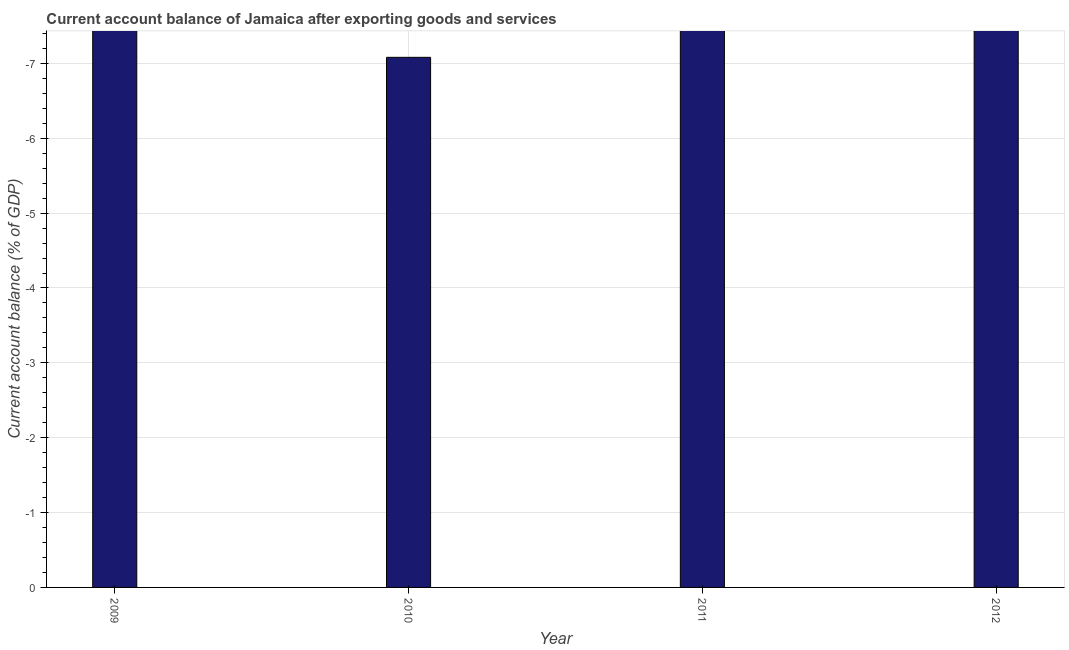What is the title of the graph?
Offer a very short reply. Current account balance of Jamaica after exporting goods and services. What is the label or title of the X-axis?
Your answer should be compact. Year. What is the label or title of the Y-axis?
Your answer should be very brief. Current account balance (% of GDP). What is the current account balance in 2010?
Give a very brief answer. 0. Across all years, what is the minimum current account balance?
Give a very brief answer. 0. What is the sum of the current account balance?
Offer a very short reply. 0. What is the median current account balance?
Provide a succinct answer. 0. In how many years, is the current account balance greater than the average current account balance taken over all years?
Your response must be concise. 0. How many years are there in the graph?
Make the answer very short. 4. What is the difference between two consecutive major ticks on the Y-axis?
Provide a succinct answer. 1. What is the Current account balance (% of GDP) in 2012?
Your answer should be compact. 0. 